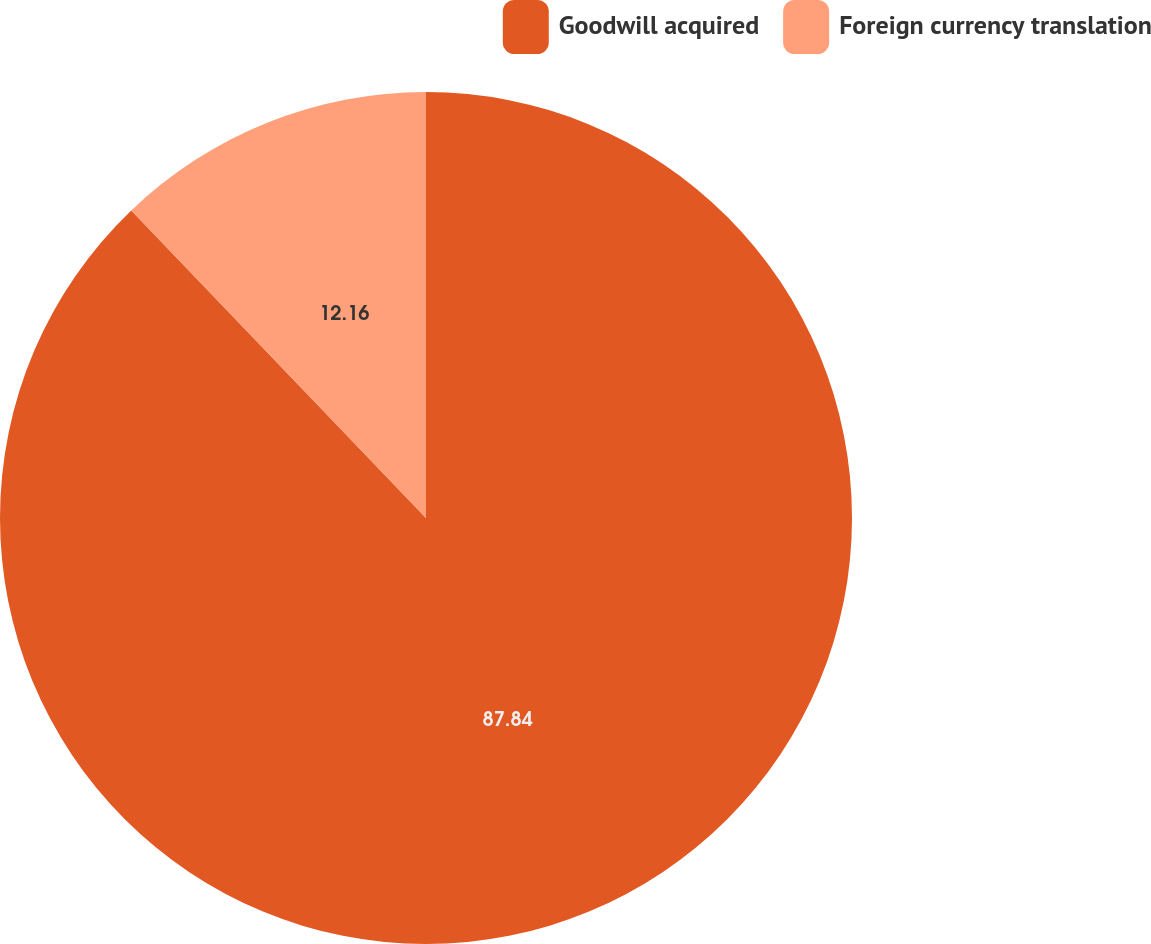Convert chart to OTSL. <chart><loc_0><loc_0><loc_500><loc_500><pie_chart><fcel>Goodwill acquired<fcel>Foreign currency translation<nl><fcel>87.84%<fcel>12.16%<nl></chart> 